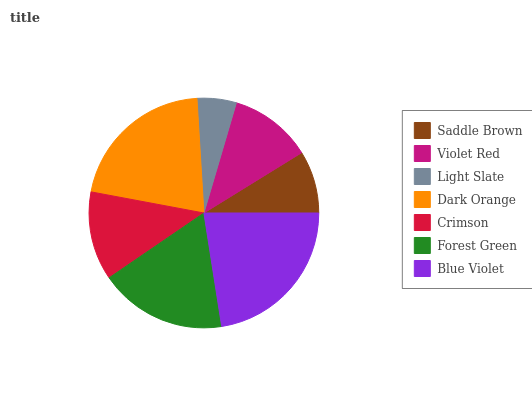Is Light Slate the minimum?
Answer yes or no. Yes. Is Blue Violet the maximum?
Answer yes or no. Yes. Is Violet Red the minimum?
Answer yes or no. No. Is Violet Red the maximum?
Answer yes or no. No. Is Violet Red greater than Saddle Brown?
Answer yes or no. Yes. Is Saddle Brown less than Violet Red?
Answer yes or no. Yes. Is Saddle Brown greater than Violet Red?
Answer yes or no. No. Is Violet Red less than Saddle Brown?
Answer yes or no. No. Is Crimson the high median?
Answer yes or no. Yes. Is Crimson the low median?
Answer yes or no. Yes. Is Dark Orange the high median?
Answer yes or no. No. Is Forest Green the low median?
Answer yes or no. No. 